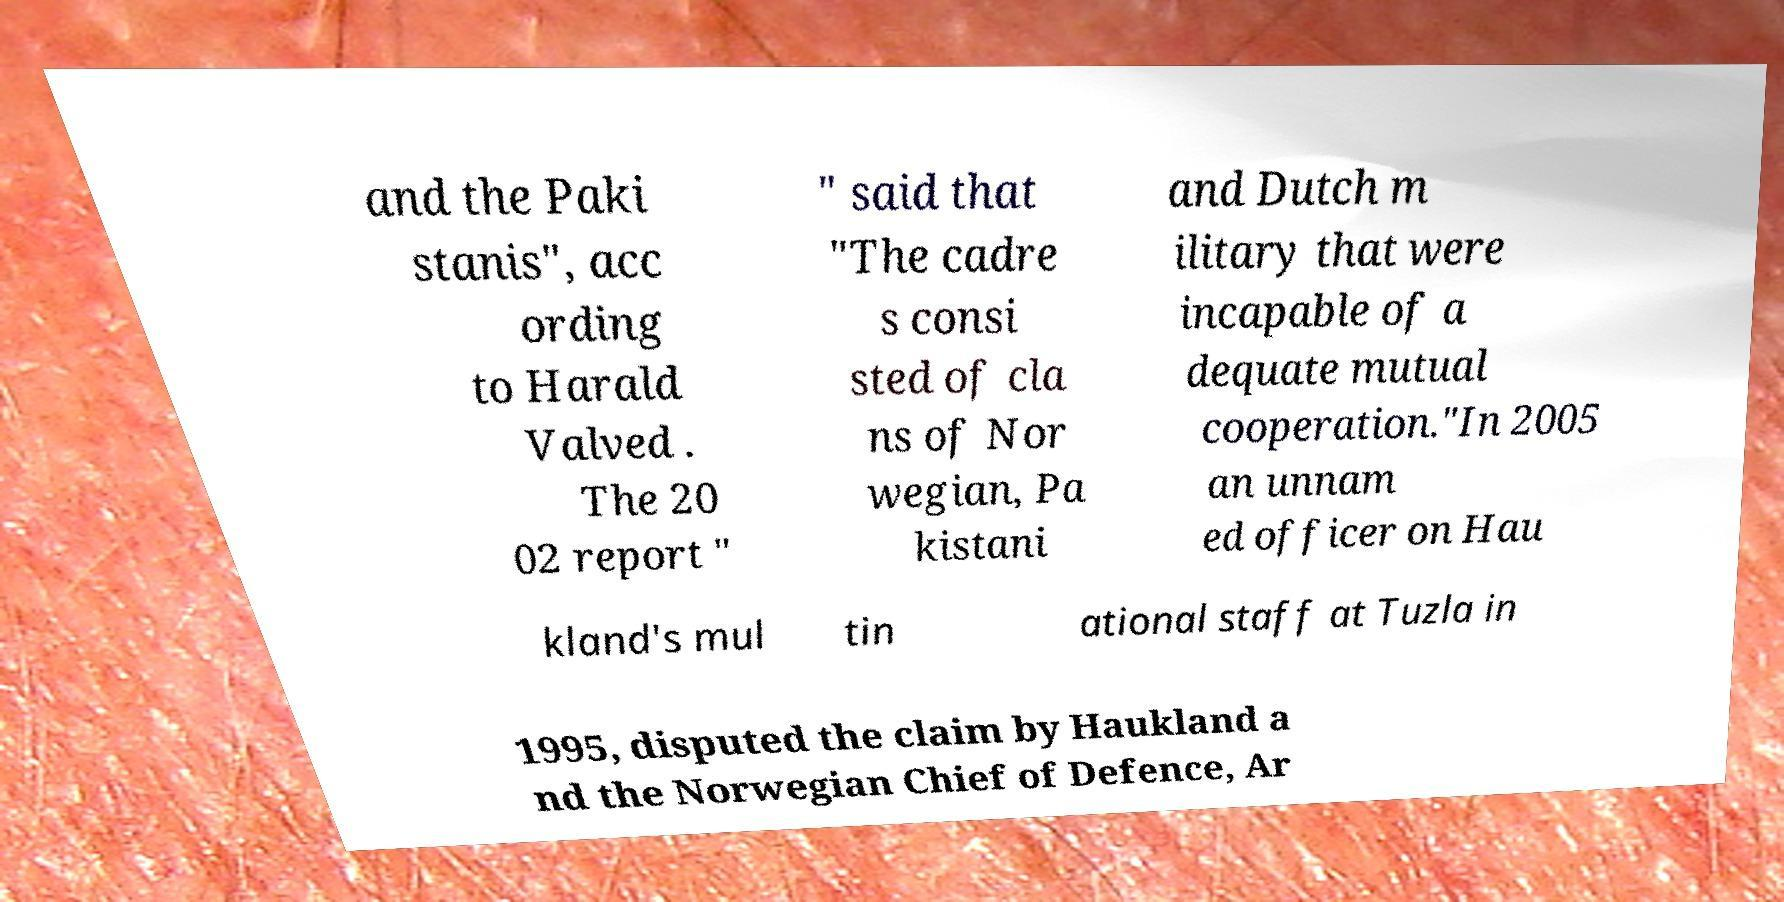Can you accurately transcribe the text from the provided image for me? and the Paki stanis", acc ording to Harald Valved . The 20 02 report " " said that "The cadre s consi sted of cla ns of Nor wegian, Pa kistani and Dutch m ilitary that were incapable of a dequate mutual cooperation."In 2005 an unnam ed officer on Hau kland's mul tin ational staff at Tuzla in 1995, disputed the claim by Haukland a nd the Norwegian Chief of Defence, Ar 